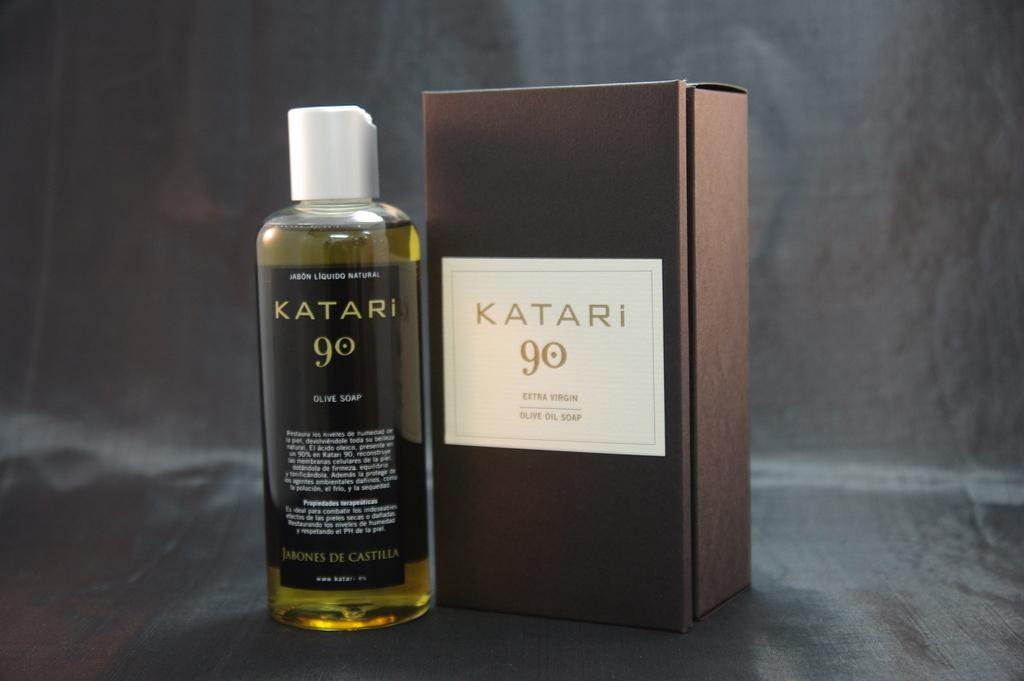Provide a one-sentence caption for the provided image. Box of Katari 90 and a bottle of Katari 90. 